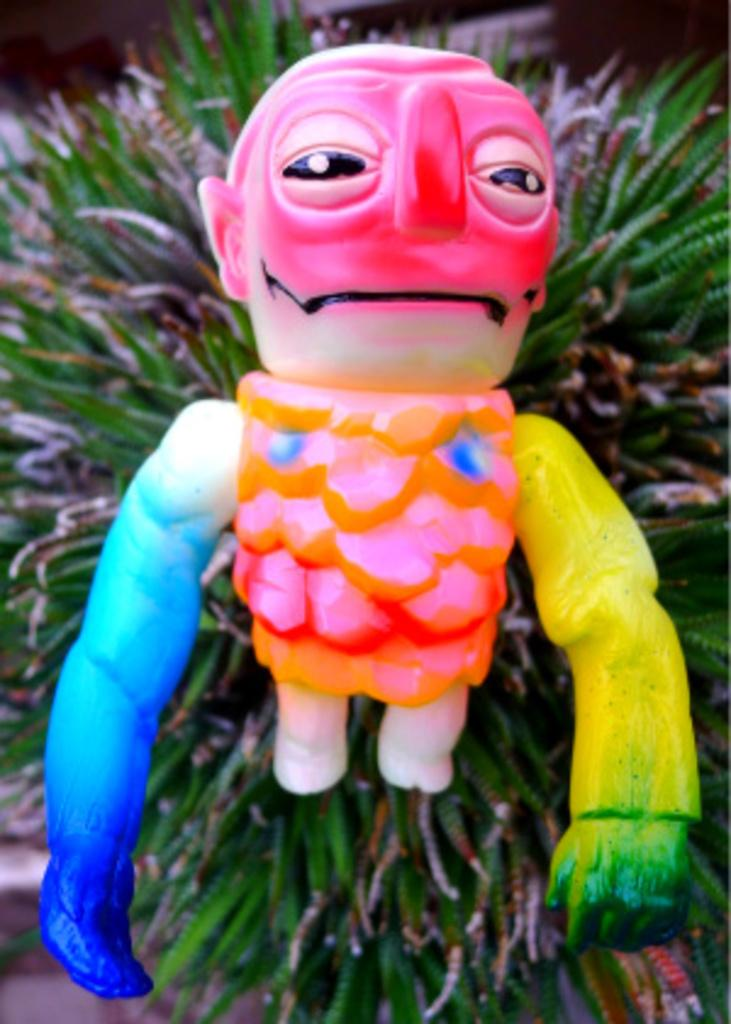What object is present on the plant in the image? There is a toy on the plant in the image. Where is the toy located in relation to the plant? The toy is on the floor, and it is also on the plant. What can be said about the appearance of the toy? The toy has multiple colors. What type of request can be seen on the plate in the image? There is no plate present in the image, and therefore no request can be seen. 